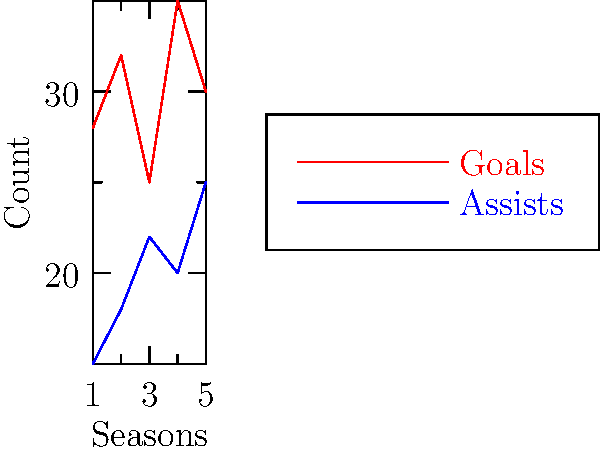Based on the line graph showing your performance statistics over five seasons, in which season did you have the highest combined total of goals and assists? To determine the season with the highest combined total of goals and assists, we need to:

1. Calculate the sum of goals and assists for each season:
   Season 1: 28 + 15 = 43
   Season 2: 32 + 18 = 50
   Season 3: 25 + 22 = 47
   Season 4: 35 + 20 = 55
   Season 5: 30 + 25 = 55

2. Compare the totals:
   Season 1: 43
   Season 2: 50
   Season 3: 47
   Season 4: 55
   Season 5: 55

3. Identify the highest total:
   Seasons 4 and 5 both have the highest total of 55.

4. Since the question asks for a single season, we'll choose the earlier of the two tied seasons.

Therefore, Season 4 had the highest combined total of goals and assists.
Answer: Season 4 